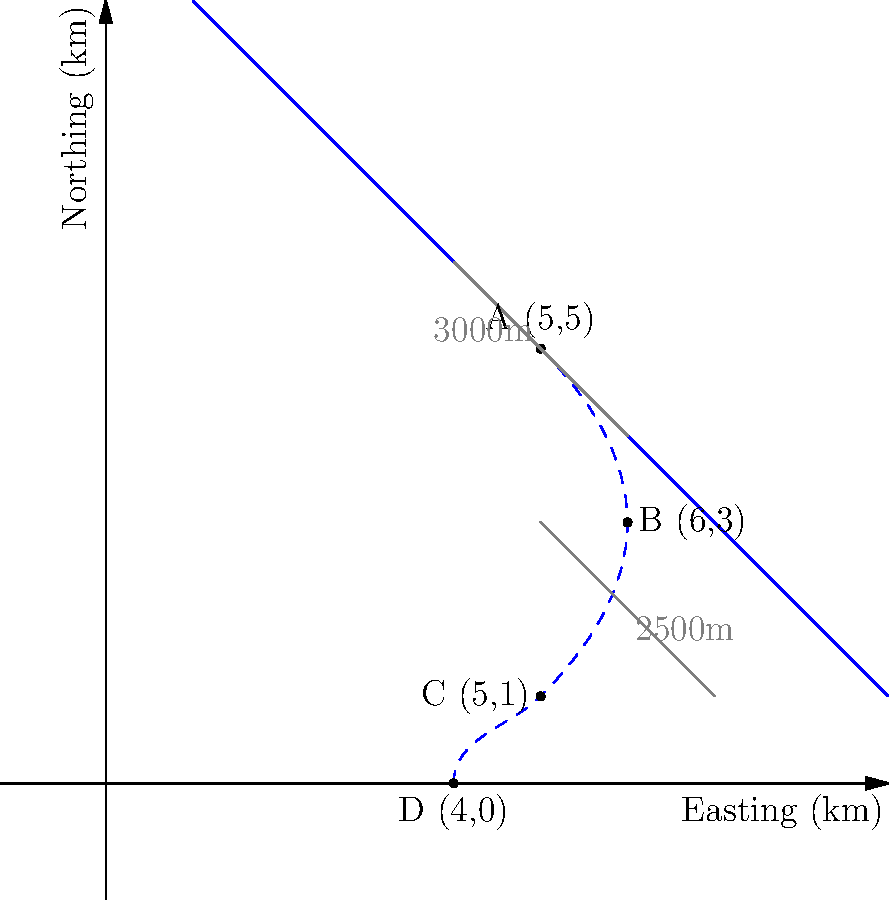A glacier's meltwater path is mapped using a coordinate system where each unit represents 1 km. The path starts at point A (5,5) with an elevation of 3000m and ends at point D (4,0). It passes through intermediate points B (6,3) and C (5,1), with point C at an elevation of 2500m. Calculate the total horizontal distance traveled by the meltwater and the average slope (in degrees) of the path between points A and C. To solve this problem, we'll follow these steps:

1. Calculate the total horizontal distance:
   - Use the distance formula between consecutive points
   - $d = \sqrt{(x_2-x_1)^2 + (y_2-y_1)^2}$
   
   AB: $d_{AB} = \sqrt{(6-5)^2 + (3-5)^2} = \sqrt{1^2 + (-2)^2} = \sqrt{5}$ km
   BC: $d_{BC} = \sqrt{(5-6)^2 + (1-3)^2} = \sqrt{1^2 + (-2)^2} = \sqrt{5}$ km
   CD: $d_{CD} = \sqrt{(4-5)^2 + (0-1)^2} = \sqrt{1^2 + (-1)^2} = \sqrt{2}$ km
   
   Total horizontal distance = $\sqrt{5} + \sqrt{5} + \sqrt{2} = 2\sqrt{5} + \sqrt{2}$ km

2. Calculate the average slope between A and C:
   - Horizontal distance AC: $d_{AC} = \sqrt{(5-5)^2 + (1-5)^2} = 4$ km
   - Vertical drop: 3000m - 2500m = 500m = 0.5 km
   - Slope = rise / run = 0.5 / 4 = 0.125
   - Angle = $\arctan(0.125)$
   - Convert to degrees: $\arctan(0.125) * (180/\pi) \approx 7.13°$
Answer: Total horizontal distance: $2\sqrt{5} + \sqrt{2}$ km; Average slope A to C: 7.13° 